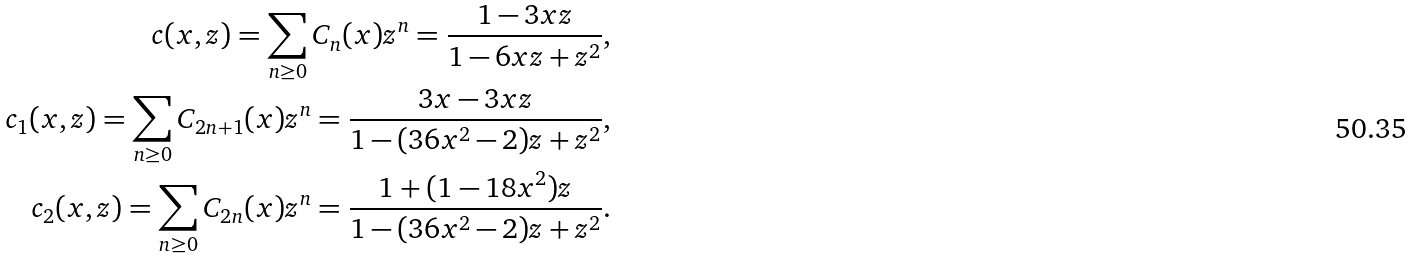Convert formula to latex. <formula><loc_0><loc_0><loc_500><loc_500>c ( x , z ) = \sum _ { n \geq 0 } C _ { n } ( x ) z ^ { n } = \frac { 1 - 3 x z } { 1 - 6 x z + z ^ { 2 } } , \\ c _ { 1 } ( x , z ) = \sum _ { n \geq 0 } C _ { 2 n + 1 } ( x ) z ^ { n } = \frac { 3 x - 3 x z } { 1 - ( 3 6 x ^ { 2 } - 2 ) z + z ^ { 2 } } , \\ c _ { 2 } ( x , z ) = \sum _ { n \geq 0 } C _ { 2 n } ( x ) z ^ { n } = \frac { 1 + ( 1 - 1 8 x ^ { 2 } ) z } { 1 - ( 3 6 x ^ { 2 } - 2 ) z + z ^ { 2 } } .</formula> 